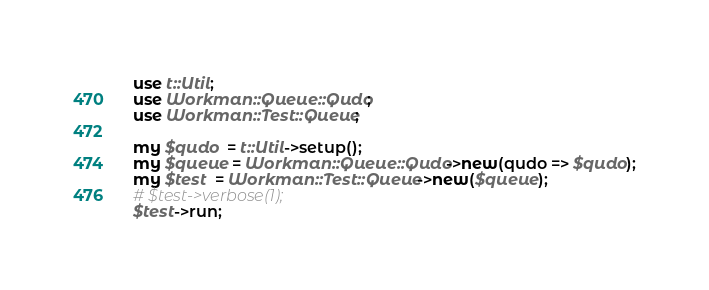<code> <loc_0><loc_0><loc_500><loc_500><_Perl_>
use t::Util;
use Workman::Queue::Qudo;
use Workman::Test::Queue;

my $qudo  = t::Util->setup();
my $queue = Workman::Queue::Qudo->new(qudo => $qudo);
my $test  = Workman::Test::Queue->new($queue);
# $test->verbose(1);
$test->run;
</code> 